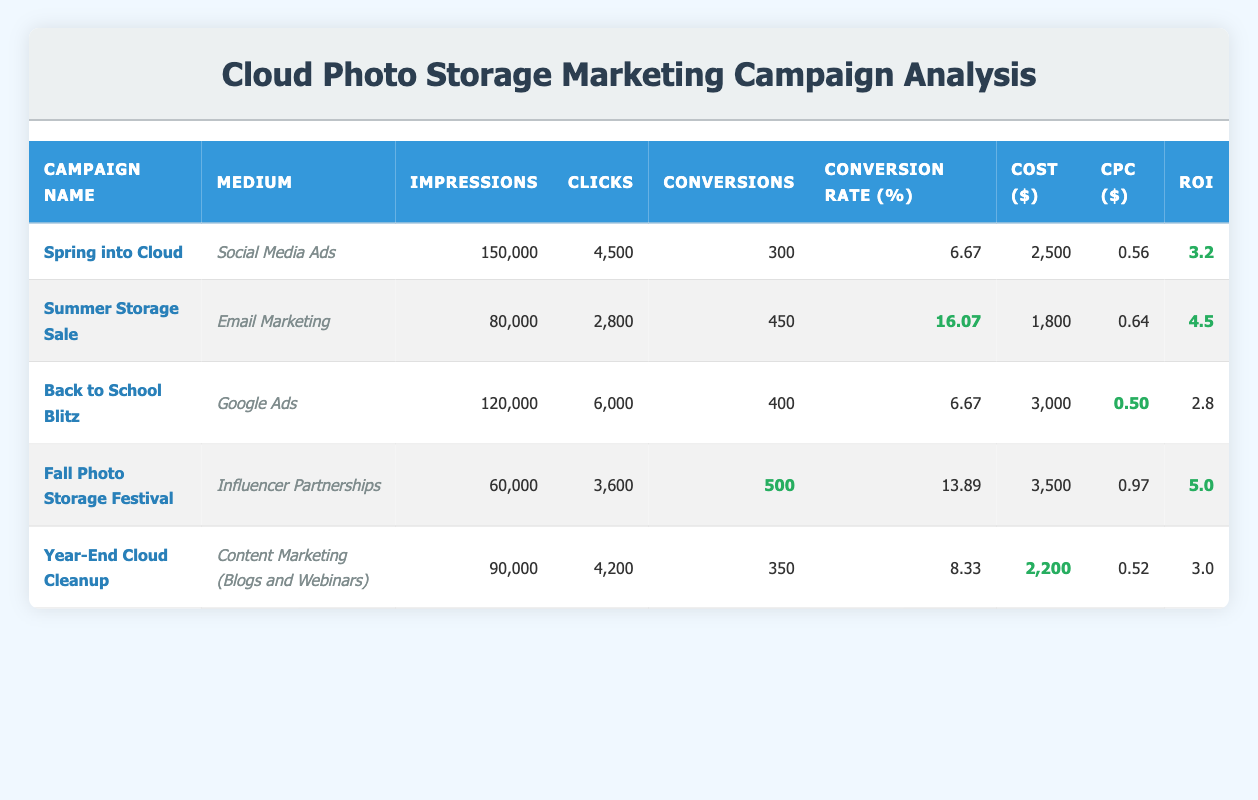What was the conversion rate for the "Summer Storage Sale" campaign? The conversion rate for a campaign is given in the table as a percentage. For the "Summer Storage Sale," the value is listed directly under the "Conversion Rate (%)" column.
Answer: 16.07 Which campaign had the highest ROI? To find the campaign with the highest ROI, we compare the ROI values across all campaigns in the table. The "Fall Photo Storage Festival" has the highest ROI value of 5.0.
Answer: Fall Photo Storage Festival What was the total cost of all marketing campaigns? To calculate the total cost, we sum the "Cost ($)" values from all campaigns: 2500 + 1800 + 3000 + 3500 + 2200 = 15500.
Answer: 15500 Did the "Back to School Blitz" campaign have a conversion rate lower than 10%? The conversion rate for the "Back to School Blitz" is 6.67%, which is indeed lower than 10%. Therefore, the statement is true.
Answer: Yes What is the average Conversion Rate of all campaigns? First, we need to sum up the conversion rates from all campaigns: 6.67 + 16.07 + 6.67 + 13.89 + 8.33 = 51.63. Next, we divide by the number of campaigns (5): 51.63 / 5 = 10.33.
Answer: 10.33 Which medium generated the highest number of conversions? We look at the "Conversions" column for each campaign's medium. "Fall Photo Storage Festival" has 500 conversions, which is the highest among all listed.
Answer: Fall Photo Storage Festival Was the "Year-End Cloud Cleanup" campaign more cost-effective than the "Spring into Cloud" campaign based on CPC? The "Year-End Cloud Cleanup" campaign has a CPC of 0.52, while the "Spring into Cloud" has a CPC of 0.56. Since 0.52 is lower than 0.56, the "Year-End Cloud Cleanup" is more cost-effective.
Answer: Yes How many more impressions did the "Back to School Blitz" campaign have than the "Fall Photo Storage Festival"? We subtract the impressions of the "Fall Photo Storage Festival" from those of the "Back to School Blitz": 120000 - 60000 = 60000.
Answer: 60000 What was the total number of clicks generated by all campaigns combined? To find the total number of clicks, we add the number of clicks across all campaigns: 4500 + 2800 + 6000 + 3600 + 4200 = 20600.
Answer: 20600 